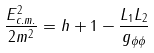<formula> <loc_0><loc_0><loc_500><loc_500>\frac { E _ { c . m . } ^ { 2 } } { 2 m ^ { 2 } } = h + 1 - \frac { L _ { 1 } L _ { 2 } } { g _ { \phi \phi } } \text { }</formula> 